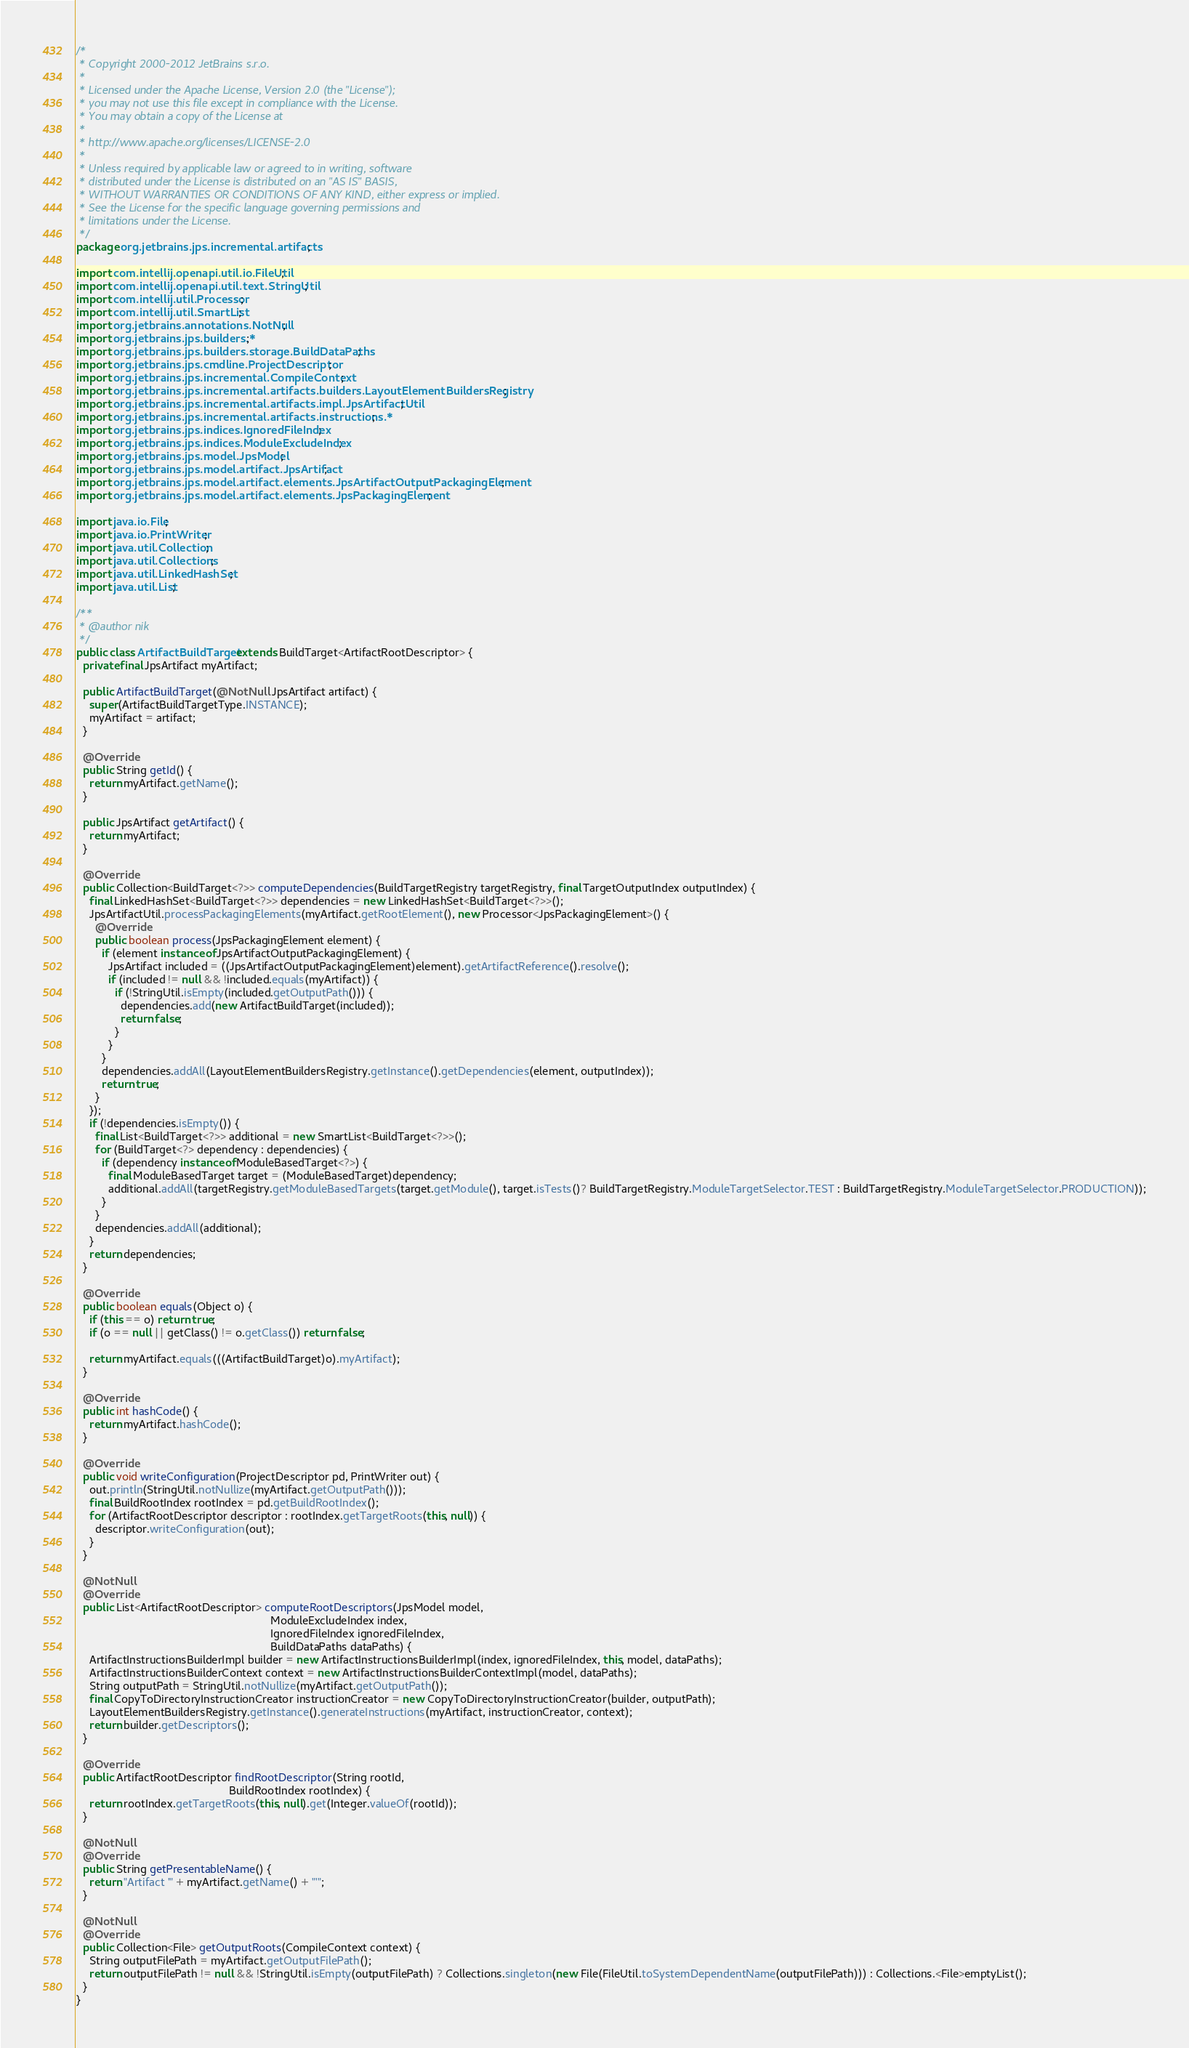Convert code to text. <code><loc_0><loc_0><loc_500><loc_500><_Java_>/*
 * Copyright 2000-2012 JetBrains s.r.o.
 *
 * Licensed under the Apache License, Version 2.0 (the "License");
 * you may not use this file except in compliance with the License.
 * You may obtain a copy of the License at
 *
 * http://www.apache.org/licenses/LICENSE-2.0
 *
 * Unless required by applicable law or agreed to in writing, software
 * distributed under the License is distributed on an "AS IS" BASIS,
 * WITHOUT WARRANTIES OR CONDITIONS OF ANY KIND, either express or implied.
 * See the License for the specific language governing permissions and
 * limitations under the License.
 */
package org.jetbrains.jps.incremental.artifacts;

import com.intellij.openapi.util.io.FileUtil;
import com.intellij.openapi.util.text.StringUtil;
import com.intellij.util.Processor;
import com.intellij.util.SmartList;
import org.jetbrains.annotations.NotNull;
import org.jetbrains.jps.builders.*;
import org.jetbrains.jps.builders.storage.BuildDataPaths;
import org.jetbrains.jps.cmdline.ProjectDescriptor;
import org.jetbrains.jps.incremental.CompileContext;
import org.jetbrains.jps.incremental.artifacts.builders.LayoutElementBuildersRegistry;
import org.jetbrains.jps.incremental.artifacts.impl.JpsArtifactUtil;
import org.jetbrains.jps.incremental.artifacts.instructions.*;
import org.jetbrains.jps.indices.IgnoredFileIndex;
import org.jetbrains.jps.indices.ModuleExcludeIndex;
import org.jetbrains.jps.model.JpsModel;
import org.jetbrains.jps.model.artifact.JpsArtifact;
import org.jetbrains.jps.model.artifact.elements.JpsArtifactOutputPackagingElement;
import org.jetbrains.jps.model.artifact.elements.JpsPackagingElement;

import java.io.File;
import java.io.PrintWriter;
import java.util.Collection;
import java.util.Collections;
import java.util.LinkedHashSet;
import java.util.List;

/**
 * @author nik
 */
public class ArtifactBuildTarget extends BuildTarget<ArtifactRootDescriptor> {
  private final JpsArtifact myArtifact;

  public ArtifactBuildTarget(@NotNull JpsArtifact artifact) {
    super(ArtifactBuildTargetType.INSTANCE);
    myArtifact = artifact;
  }

  @Override
  public String getId() {
    return myArtifact.getName();
  }

  public JpsArtifact getArtifact() {
    return myArtifact;
  }

  @Override
  public Collection<BuildTarget<?>> computeDependencies(BuildTargetRegistry targetRegistry, final TargetOutputIndex outputIndex) {
    final LinkedHashSet<BuildTarget<?>> dependencies = new LinkedHashSet<BuildTarget<?>>();
    JpsArtifactUtil.processPackagingElements(myArtifact.getRootElement(), new Processor<JpsPackagingElement>() {
      @Override
      public boolean process(JpsPackagingElement element) {
        if (element instanceof JpsArtifactOutputPackagingElement) {
          JpsArtifact included = ((JpsArtifactOutputPackagingElement)element).getArtifactReference().resolve();
          if (included != null && !included.equals(myArtifact)) {
            if (!StringUtil.isEmpty(included.getOutputPath())) {
              dependencies.add(new ArtifactBuildTarget(included));
              return false;
            }
          }
        }
        dependencies.addAll(LayoutElementBuildersRegistry.getInstance().getDependencies(element, outputIndex));
        return true;
      }
    });
    if (!dependencies.isEmpty()) {
      final List<BuildTarget<?>> additional = new SmartList<BuildTarget<?>>();
      for (BuildTarget<?> dependency : dependencies) {
        if (dependency instanceof ModuleBasedTarget<?>) {
          final ModuleBasedTarget target = (ModuleBasedTarget)dependency;
          additional.addAll(targetRegistry.getModuleBasedTargets(target.getModule(), target.isTests()? BuildTargetRegistry.ModuleTargetSelector.TEST : BuildTargetRegistry.ModuleTargetSelector.PRODUCTION));
        }
      }
      dependencies.addAll(additional);
    }
    return dependencies;
  }

  @Override
  public boolean equals(Object o) {
    if (this == o) return true;
    if (o == null || getClass() != o.getClass()) return false;

    return myArtifact.equals(((ArtifactBuildTarget)o).myArtifact);
  }

  @Override
  public int hashCode() {
    return myArtifact.hashCode();
  }

  @Override
  public void writeConfiguration(ProjectDescriptor pd, PrintWriter out) {
    out.println(StringUtil.notNullize(myArtifact.getOutputPath()));
    final BuildRootIndex rootIndex = pd.getBuildRootIndex();
    for (ArtifactRootDescriptor descriptor : rootIndex.getTargetRoots(this, null)) {
      descriptor.writeConfiguration(out);
    }
  }

  @NotNull
  @Override
  public List<ArtifactRootDescriptor> computeRootDescriptors(JpsModel model,
                                                             ModuleExcludeIndex index,
                                                             IgnoredFileIndex ignoredFileIndex,
                                                             BuildDataPaths dataPaths) {
    ArtifactInstructionsBuilderImpl builder = new ArtifactInstructionsBuilderImpl(index, ignoredFileIndex, this, model, dataPaths);
    ArtifactInstructionsBuilderContext context = new ArtifactInstructionsBuilderContextImpl(model, dataPaths);
    String outputPath = StringUtil.notNullize(myArtifact.getOutputPath());
    final CopyToDirectoryInstructionCreator instructionCreator = new CopyToDirectoryInstructionCreator(builder, outputPath);
    LayoutElementBuildersRegistry.getInstance().generateInstructions(myArtifact, instructionCreator, context);
    return builder.getDescriptors();
  }

  @Override
  public ArtifactRootDescriptor findRootDescriptor(String rootId,
                                                BuildRootIndex rootIndex) {
    return rootIndex.getTargetRoots(this, null).get(Integer.valueOf(rootId));
  }

  @NotNull
  @Override
  public String getPresentableName() {
    return "Artifact '" + myArtifact.getName() + "'";
  }

  @NotNull
  @Override
  public Collection<File> getOutputRoots(CompileContext context) {
    String outputFilePath = myArtifact.getOutputFilePath();
    return outputFilePath != null && !StringUtil.isEmpty(outputFilePath) ? Collections.singleton(new File(FileUtil.toSystemDependentName(outputFilePath))) : Collections.<File>emptyList();
  }
}
</code> 